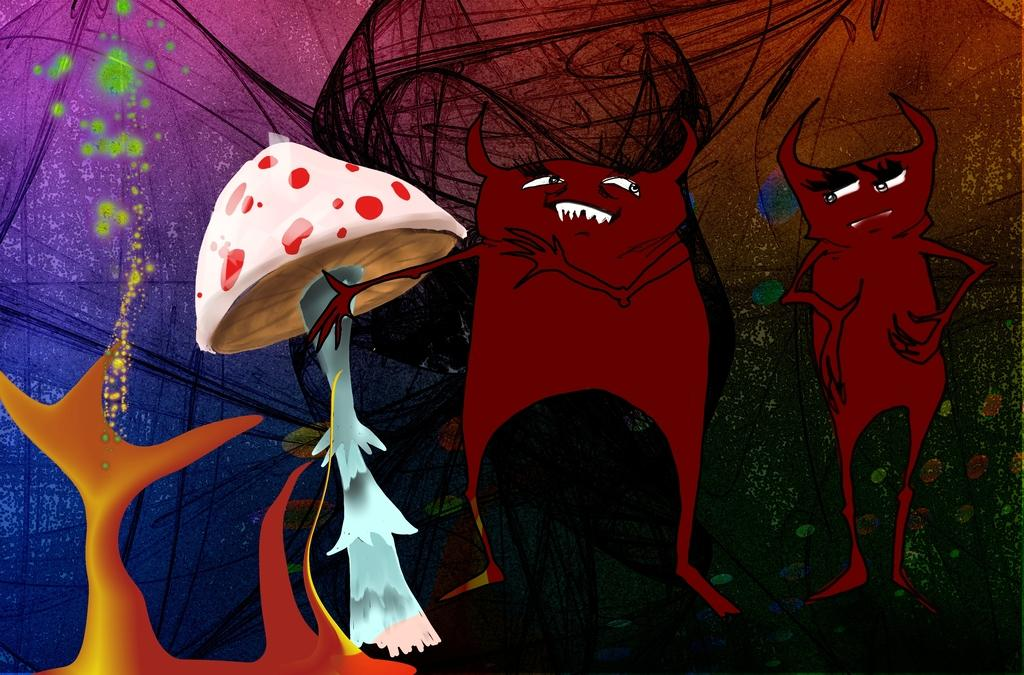What type of images are present in the picture? There are animated images of cartoon characters in the image. Can you describe any specific objects or elements in the image? Yes, there is a mushroom in the image. What type of help does the son need from the cub in the image? There is no son or cub present in the image; it only features animated cartoon characters and a mushroom. 